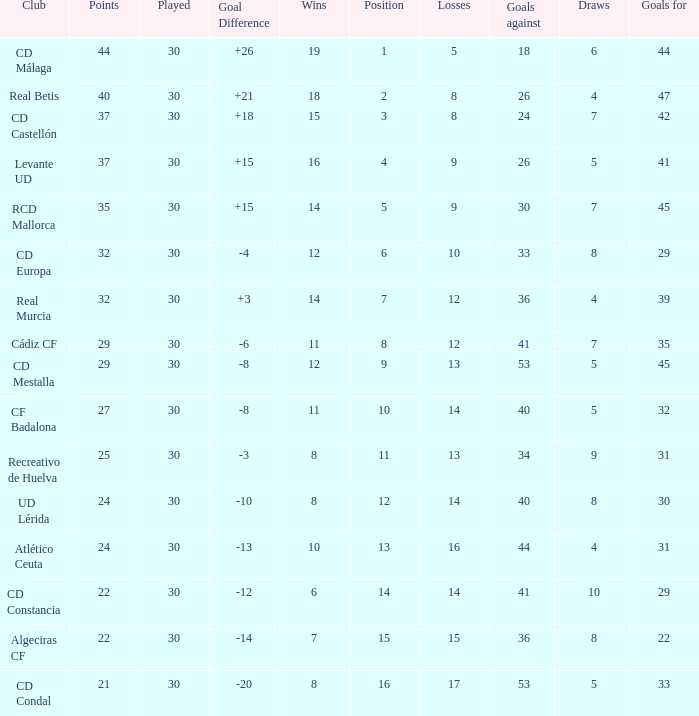What is the total wins when the points were under 27, and goals against were 41? 6.0. 